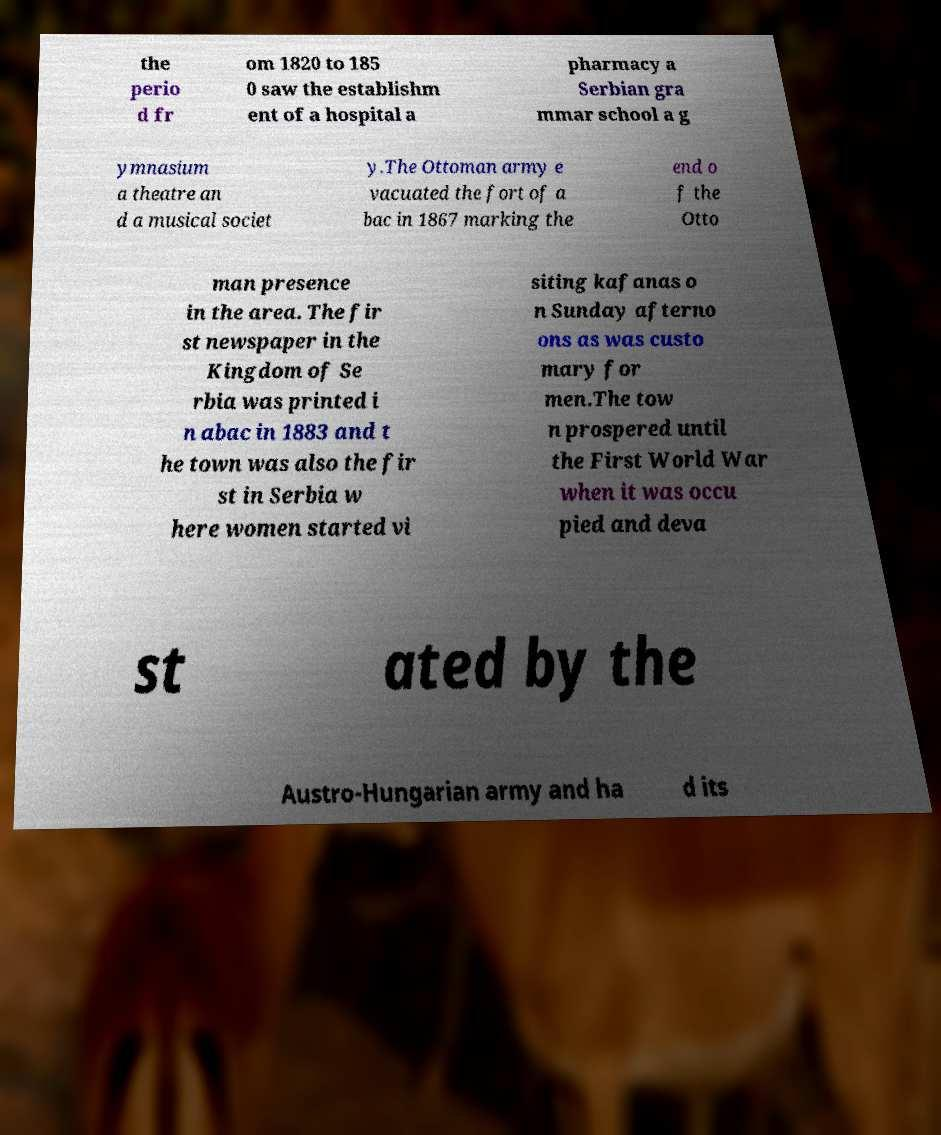I need the written content from this picture converted into text. Can you do that? the perio d fr om 1820 to 185 0 saw the establishm ent of a hospital a pharmacy a Serbian gra mmar school a g ymnasium a theatre an d a musical societ y.The Ottoman army e vacuated the fort of a bac in 1867 marking the end o f the Otto man presence in the area. The fir st newspaper in the Kingdom of Se rbia was printed i n abac in 1883 and t he town was also the fir st in Serbia w here women started vi siting kafanas o n Sunday afterno ons as was custo mary for men.The tow n prospered until the First World War when it was occu pied and deva st ated by the Austro-Hungarian army and ha d its 